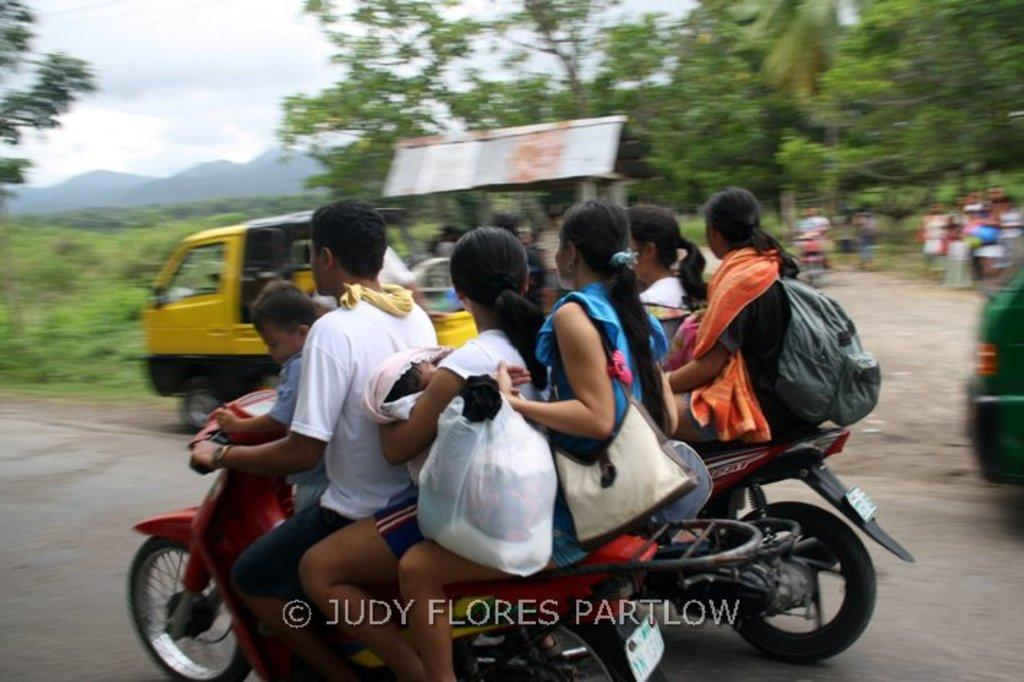What are the people in the image doing? The people in the image are riding motorbikes. What other vehicle can be seen in the image? There appears to be an auto rickshaw in the image. What can be seen in the background of the image? There are trees and mountains visible in the background of the image. Are there any other people in the image besides those riding motorbikes? Yes, there is a group of people standing in the image. What type of prose is being recited by the servant in the image? There is no servant or prose present in the image. What season is depicted in the image? The image does not depict a specific season, as there are no seasonal cues present. 